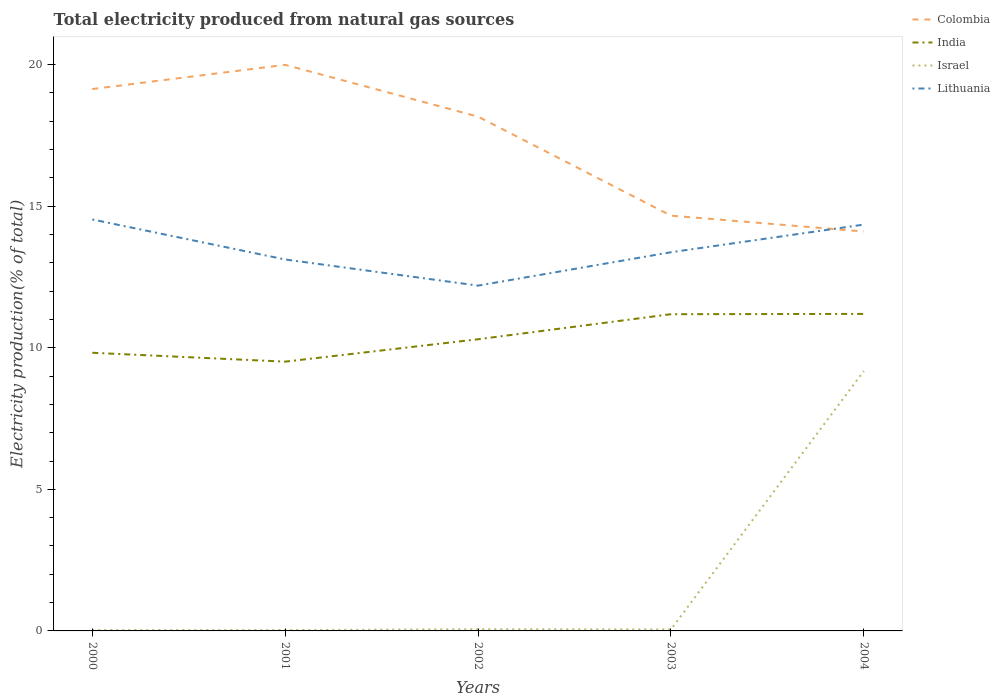How many different coloured lines are there?
Your response must be concise. 4. Does the line corresponding to Colombia intersect with the line corresponding to Lithuania?
Provide a succinct answer. Yes. Is the number of lines equal to the number of legend labels?
Your answer should be compact. Yes. Across all years, what is the maximum total electricity produced in Israel?
Your answer should be compact. 0.03. What is the total total electricity produced in Israel in the graph?
Provide a succinct answer. 0.01. What is the difference between the highest and the second highest total electricity produced in Lithuania?
Provide a succinct answer. 2.34. What is the difference between the highest and the lowest total electricity produced in Israel?
Provide a succinct answer. 1. Is the total electricity produced in Israel strictly greater than the total electricity produced in Colombia over the years?
Your response must be concise. Yes. How many lines are there?
Offer a very short reply. 4. How many years are there in the graph?
Give a very brief answer. 5. Where does the legend appear in the graph?
Your answer should be compact. Top right. How many legend labels are there?
Your answer should be very brief. 4. What is the title of the graph?
Make the answer very short. Total electricity produced from natural gas sources. Does "Austria" appear as one of the legend labels in the graph?
Give a very brief answer. No. What is the Electricity production(% of total) of Colombia in 2000?
Offer a terse response. 19.14. What is the Electricity production(% of total) in India in 2000?
Your response must be concise. 9.82. What is the Electricity production(% of total) in Israel in 2000?
Give a very brief answer. 0.03. What is the Electricity production(% of total) in Lithuania in 2000?
Your answer should be very brief. 14.53. What is the Electricity production(% of total) in Colombia in 2001?
Give a very brief answer. 19.99. What is the Electricity production(% of total) in India in 2001?
Your response must be concise. 9.51. What is the Electricity production(% of total) in Israel in 2001?
Give a very brief answer. 0.03. What is the Electricity production(% of total) in Lithuania in 2001?
Provide a succinct answer. 13.12. What is the Electricity production(% of total) of Colombia in 2002?
Provide a short and direct response. 18.16. What is the Electricity production(% of total) of India in 2002?
Make the answer very short. 10.3. What is the Electricity production(% of total) in Israel in 2002?
Your answer should be compact. 0.06. What is the Electricity production(% of total) of Lithuania in 2002?
Your response must be concise. 12.19. What is the Electricity production(% of total) of Colombia in 2003?
Give a very brief answer. 14.67. What is the Electricity production(% of total) of India in 2003?
Make the answer very short. 11.19. What is the Electricity production(% of total) in Israel in 2003?
Your response must be concise. 0.05. What is the Electricity production(% of total) of Lithuania in 2003?
Provide a succinct answer. 13.37. What is the Electricity production(% of total) in Colombia in 2004?
Your answer should be compact. 14.11. What is the Electricity production(% of total) in India in 2004?
Keep it short and to the point. 11.2. What is the Electricity production(% of total) of Israel in 2004?
Your answer should be very brief. 9.18. What is the Electricity production(% of total) in Lithuania in 2004?
Keep it short and to the point. 14.35. Across all years, what is the maximum Electricity production(% of total) of Colombia?
Offer a very short reply. 19.99. Across all years, what is the maximum Electricity production(% of total) in India?
Your answer should be compact. 11.2. Across all years, what is the maximum Electricity production(% of total) in Israel?
Your answer should be very brief. 9.18. Across all years, what is the maximum Electricity production(% of total) in Lithuania?
Ensure brevity in your answer.  14.53. Across all years, what is the minimum Electricity production(% of total) in Colombia?
Your response must be concise. 14.11. Across all years, what is the minimum Electricity production(% of total) in India?
Make the answer very short. 9.51. Across all years, what is the minimum Electricity production(% of total) of Israel?
Offer a terse response. 0.03. Across all years, what is the minimum Electricity production(% of total) of Lithuania?
Keep it short and to the point. 12.19. What is the total Electricity production(% of total) in Colombia in the graph?
Ensure brevity in your answer.  86.06. What is the total Electricity production(% of total) in India in the graph?
Keep it short and to the point. 52.02. What is the total Electricity production(% of total) in Israel in the graph?
Keep it short and to the point. 9.36. What is the total Electricity production(% of total) of Lithuania in the graph?
Keep it short and to the point. 67.57. What is the difference between the Electricity production(% of total) of Colombia in 2000 and that in 2001?
Your response must be concise. -0.85. What is the difference between the Electricity production(% of total) of India in 2000 and that in 2001?
Your answer should be very brief. 0.31. What is the difference between the Electricity production(% of total) of Israel in 2000 and that in 2001?
Make the answer very short. 0. What is the difference between the Electricity production(% of total) of Lithuania in 2000 and that in 2001?
Your answer should be very brief. 1.41. What is the difference between the Electricity production(% of total) in Colombia in 2000 and that in 2002?
Your answer should be compact. 0.97. What is the difference between the Electricity production(% of total) of India in 2000 and that in 2002?
Your answer should be very brief. -0.48. What is the difference between the Electricity production(% of total) of Israel in 2000 and that in 2002?
Your answer should be very brief. -0.03. What is the difference between the Electricity production(% of total) in Lithuania in 2000 and that in 2002?
Your response must be concise. 2.34. What is the difference between the Electricity production(% of total) in Colombia in 2000 and that in 2003?
Your answer should be very brief. 4.47. What is the difference between the Electricity production(% of total) of India in 2000 and that in 2003?
Offer a terse response. -1.36. What is the difference between the Electricity production(% of total) in Israel in 2000 and that in 2003?
Offer a terse response. -0.02. What is the difference between the Electricity production(% of total) in Lithuania in 2000 and that in 2003?
Keep it short and to the point. 1.16. What is the difference between the Electricity production(% of total) in Colombia in 2000 and that in 2004?
Offer a terse response. 5.03. What is the difference between the Electricity production(% of total) in India in 2000 and that in 2004?
Your answer should be very brief. -1.37. What is the difference between the Electricity production(% of total) of Israel in 2000 and that in 2004?
Ensure brevity in your answer.  -9.15. What is the difference between the Electricity production(% of total) of Lithuania in 2000 and that in 2004?
Make the answer very short. 0.18. What is the difference between the Electricity production(% of total) in Colombia in 2001 and that in 2002?
Your response must be concise. 1.83. What is the difference between the Electricity production(% of total) of India in 2001 and that in 2002?
Keep it short and to the point. -0.79. What is the difference between the Electricity production(% of total) of Israel in 2001 and that in 2002?
Offer a terse response. -0.03. What is the difference between the Electricity production(% of total) of Lithuania in 2001 and that in 2002?
Provide a short and direct response. 0.92. What is the difference between the Electricity production(% of total) in Colombia in 2001 and that in 2003?
Your response must be concise. 5.33. What is the difference between the Electricity production(% of total) of India in 2001 and that in 2003?
Give a very brief answer. -1.68. What is the difference between the Electricity production(% of total) in Israel in 2001 and that in 2003?
Your response must be concise. -0.02. What is the difference between the Electricity production(% of total) of Lithuania in 2001 and that in 2003?
Ensure brevity in your answer.  -0.26. What is the difference between the Electricity production(% of total) of Colombia in 2001 and that in 2004?
Your answer should be compact. 5.89. What is the difference between the Electricity production(% of total) of India in 2001 and that in 2004?
Keep it short and to the point. -1.69. What is the difference between the Electricity production(% of total) in Israel in 2001 and that in 2004?
Provide a short and direct response. -9.15. What is the difference between the Electricity production(% of total) in Lithuania in 2001 and that in 2004?
Provide a succinct answer. -1.23. What is the difference between the Electricity production(% of total) in Colombia in 2002 and that in 2003?
Your answer should be very brief. 3.5. What is the difference between the Electricity production(% of total) of India in 2002 and that in 2003?
Your answer should be compact. -0.89. What is the difference between the Electricity production(% of total) in Israel in 2002 and that in 2003?
Your answer should be compact. 0.01. What is the difference between the Electricity production(% of total) of Lithuania in 2002 and that in 2003?
Provide a short and direct response. -1.18. What is the difference between the Electricity production(% of total) of Colombia in 2002 and that in 2004?
Offer a terse response. 4.06. What is the difference between the Electricity production(% of total) in India in 2002 and that in 2004?
Ensure brevity in your answer.  -0.9. What is the difference between the Electricity production(% of total) in Israel in 2002 and that in 2004?
Provide a short and direct response. -9.12. What is the difference between the Electricity production(% of total) of Lithuania in 2002 and that in 2004?
Give a very brief answer. -2.16. What is the difference between the Electricity production(% of total) of Colombia in 2003 and that in 2004?
Provide a short and direct response. 0.56. What is the difference between the Electricity production(% of total) in India in 2003 and that in 2004?
Provide a short and direct response. -0.01. What is the difference between the Electricity production(% of total) of Israel in 2003 and that in 2004?
Provide a succinct answer. -9.13. What is the difference between the Electricity production(% of total) of Lithuania in 2003 and that in 2004?
Provide a short and direct response. -0.98. What is the difference between the Electricity production(% of total) of Colombia in 2000 and the Electricity production(% of total) of India in 2001?
Provide a short and direct response. 9.63. What is the difference between the Electricity production(% of total) in Colombia in 2000 and the Electricity production(% of total) in Israel in 2001?
Offer a terse response. 19.11. What is the difference between the Electricity production(% of total) of Colombia in 2000 and the Electricity production(% of total) of Lithuania in 2001?
Offer a very short reply. 6.02. What is the difference between the Electricity production(% of total) in India in 2000 and the Electricity production(% of total) in Israel in 2001?
Offer a very short reply. 9.79. What is the difference between the Electricity production(% of total) of India in 2000 and the Electricity production(% of total) of Lithuania in 2001?
Offer a very short reply. -3.29. What is the difference between the Electricity production(% of total) in Israel in 2000 and the Electricity production(% of total) in Lithuania in 2001?
Keep it short and to the point. -13.09. What is the difference between the Electricity production(% of total) of Colombia in 2000 and the Electricity production(% of total) of India in 2002?
Make the answer very short. 8.84. What is the difference between the Electricity production(% of total) in Colombia in 2000 and the Electricity production(% of total) in Israel in 2002?
Make the answer very short. 19.08. What is the difference between the Electricity production(% of total) in Colombia in 2000 and the Electricity production(% of total) in Lithuania in 2002?
Keep it short and to the point. 6.94. What is the difference between the Electricity production(% of total) of India in 2000 and the Electricity production(% of total) of Israel in 2002?
Give a very brief answer. 9.76. What is the difference between the Electricity production(% of total) of India in 2000 and the Electricity production(% of total) of Lithuania in 2002?
Ensure brevity in your answer.  -2.37. What is the difference between the Electricity production(% of total) of Israel in 2000 and the Electricity production(% of total) of Lithuania in 2002?
Make the answer very short. -12.16. What is the difference between the Electricity production(% of total) of Colombia in 2000 and the Electricity production(% of total) of India in 2003?
Provide a short and direct response. 7.95. What is the difference between the Electricity production(% of total) in Colombia in 2000 and the Electricity production(% of total) in Israel in 2003?
Your response must be concise. 19.08. What is the difference between the Electricity production(% of total) of Colombia in 2000 and the Electricity production(% of total) of Lithuania in 2003?
Ensure brevity in your answer.  5.76. What is the difference between the Electricity production(% of total) in India in 2000 and the Electricity production(% of total) in Israel in 2003?
Your answer should be compact. 9.77. What is the difference between the Electricity production(% of total) in India in 2000 and the Electricity production(% of total) in Lithuania in 2003?
Offer a very short reply. -3.55. What is the difference between the Electricity production(% of total) of Israel in 2000 and the Electricity production(% of total) of Lithuania in 2003?
Your response must be concise. -13.34. What is the difference between the Electricity production(% of total) of Colombia in 2000 and the Electricity production(% of total) of India in 2004?
Keep it short and to the point. 7.94. What is the difference between the Electricity production(% of total) in Colombia in 2000 and the Electricity production(% of total) in Israel in 2004?
Your response must be concise. 9.96. What is the difference between the Electricity production(% of total) of Colombia in 2000 and the Electricity production(% of total) of Lithuania in 2004?
Offer a terse response. 4.79. What is the difference between the Electricity production(% of total) in India in 2000 and the Electricity production(% of total) in Israel in 2004?
Provide a short and direct response. 0.64. What is the difference between the Electricity production(% of total) in India in 2000 and the Electricity production(% of total) in Lithuania in 2004?
Ensure brevity in your answer.  -4.53. What is the difference between the Electricity production(% of total) in Israel in 2000 and the Electricity production(% of total) in Lithuania in 2004?
Offer a very short reply. -14.32. What is the difference between the Electricity production(% of total) of Colombia in 2001 and the Electricity production(% of total) of India in 2002?
Your answer should be very brief. 9.69. What is the difference between the Electricity production(% of total) of Colombia in 2001 and the Electricity production(% of total) of Israel in 2002?
Make the answer very short. 19.93. What is the difference between the Electricity production(% of total) in Colombia in 2001 and the Electricity production(% of total) in Lithuania in 2002?
Your answer should be compact. 7.8. What is the difference between the Electricity production(% of total) in India in 2001 and the Electricity production(% of total) in Israel in 2002?
Give a very brief answer. 9.45. What is the difference between the Electricity production(% of total) in India in 2001 and the Electricity production(% of total) in Lithuania in 2002?
Your answer should be very brief. -2.69. What is the difference between the Electricity production(% of total) of Israel in 2001 and the Electricity production(% of total) of Lithuania in 2002?
Make the answer very short. -12.17. What is the difference between the Electricity production(% of total) in Colombia in 2001 and the Electricity production(% of total) in India in 2003?
Make the answer very short. 8.81. What is the difference between the Electricity production(% of total) of Colombia in 2001 and the Electricity production(% of total) of Israel in 2003?
Provide a short and direct response. 19.94. What is the difference between the Electricity production(% of total) of Colombia in 2001 and the Electricity production(% of total) of Lithuania in 2003?
Your answer should be compact. 6.62. What is the difference between the Electricity production(% of total) of India in 2001 and the Electricity production(% of total) of Israel in 2003?
Ensure brevity in your answer.  9.46. What is the difference between the Electricity production(% of total) of India in 2001 and the Electricity production(% of total) of Lithuania in 2003?
Give a very brief answer. -3.86. What is the difference between the Electricity production(% of total) in Israel in 2001 and the Electricity production(% of total) in Lithuania in 2003?
Offer a terse response. -13.34. What is the difference between the Electricity production(% of total) in Colombia in 2001 and the Electricity production(% of total) in India in 2004?
Ensure brevity in your answer.  8.8. What is the difference between the Electricity production(% of total) in Colombia in 2001 and the Electricity production(% of total) in Israel in 2004?
Keep it short and to the point. 10.81. What is the difference between the Electricity production(% of total) in Colombia in 2001 and the Electricity production(% of total) in Lithuania in 2004?
Your response must be concise. 5.64. What is the difference between the Electricity production(% of total) in India in 2001 and the Electricity production(% of total) in Israel in 2004?
Your answer should be compact. 0.33. What is the difference between the Electricity production(% of total) of India in 2001 and the Electricity production(% of total) of Lithuania in 2004?
Provide a succinct answer. -4.84. What is the difference between the Electricity production(% of total) of Israel in 2001 and the Electricity production(% of total) of Lithuania in 2004?
Make the answer very short. -14.32. What is the difference between the Electricity production(% of total) in Colombia in 2002 and the Electricity production(% of total) in India in 2003?
Offer a very short reply. 6.98. What is the difference between the Electricity production(% of total) of Colombia in 2002 and the Electricity production(% of total) of Israel in 2003?
Your response must be concise. 18.11. What is the difference between the Electricity production(% of total) in Colombia in 2002 and the Electricity production(% of total) in Lithuania in 2003?
Make the answer very short. 4.79. What is the difference between the Electricity production(% of total) of India in 2002 and the Electricity production(% of total) of Israel in 2003?
Provide a short and direct response. 10.25. What is the difference between the Electricity production(% of total) of India in 2002 and the Electricity production(% of total) of Lithuania in 2003?
Offer a terse response. -3.07. What is the difference between the Electricity production(% of total) in Israel in 2002 and the Electricity production(% of total) in Lithuania in 2003?
Your answer should be very brief. -13.31. What is the difference between the Electricity production(% of total) of Colombia in 2002 and the Electricity production(% of total) of India in 2004?
Your response must be concise. 6.97. What is the difference between the Electricity production(% of total) in Colombia in 2002 and the Electricity production(% of total) in Israel in 2004?
Offer a very short reply. 8.98. What is the difference between the Electricity production(% of total) of Colombia in 2002 and the Electricity production(% of total) of Lithuania in 2004?
Make the answer very short. 3.81. What is the difference between the Electricity production(% of total) of India in 2002 and the Electricity production(% of total) of Israel in 2004?
Keep it short and to the point. 1.12. What is the difference between the Electricity production(% of total) in India in 2002 and the Electricity production(% of total) in Lithuania in 2004?
Ensure brevity in your answer.  -4.05. What is the difference between the Electricity production(% of total) of Israel in 2002 and the Electricity production(% of total) of Lithuania in 2004?
Your answer should be very brief. -14.29. What is the difference between the Electricity production(% of total) of Colombia in 2003 and the Electricity production(% of total) of India in 2004?
Offer a terse response. 3.47. What is the difference between the Electricity production(% of total) of Colombia in 2003 and the Electricity production(% of total) of Israel in 2004?
Offer a very short reply. 5.49. What is the difference between the Electricity production(% of total) of Colombia in 2003 and the Electricity production(% of total) of Lithuania in 2004?
Your answer should be compact. 0.32. What is the difference between the Electricity production(% of total) in India in 2003 and the Electricity production(% of total) in Israel in 2004?
Provide a short and direct response. 2. What is the difference between the Electricity production(% of total) in India in 2003 and the Electricity production(% of total) in Lithuania in 2004?
Offer a terse response. -3.16. What is the difference between the Electricity production(% of total) in Israel in 2003 and the Electricity production(% of total) in Lithuania in 2004?
Provide a short and direct response. -14.3. What is the average Electricity production(% of total) in Colombia per year?
Your answer should be very brief. 17.21. What is the average Electricity production(% of total) of India per year?
Offer a terse response. 10.4. What is the average Electricity production(% of total) of Israel per year?
Make the answer very short. 1.87. What is the average Electricity production(% of total) of Lithuania per year?
Provide a short and direct response. 13.51. In the year 2000, what is the difference between the Electricity production(% of total) in Colombia and Electricity production(% of total) in India?
Provide a succinct answer. 9.31. In the year 2000, what is the difference between the Electricity production(% of total) in Colombia and Electricity production(% of total) in Israel?
Provide a short and direct response. 19.11. In the year 2000, what is the difference between the Electricity production(% of total) of Colombia and Electricity production(% of total) of Lithuania?
Your answer should be compact. 4.61. In the year 2000, what is the difference between the Electricity production(% of total) of India and Electricity production(% of total) of Israel?
Keep it short and to the point. 9.79. In the year 2000, what is the difference between the Electricity production(% of total) in India and Electricity production(% of total) in Lithuania?
Your answer should be very brief. -4.71. In the year 2000, what is the difference between the Electricity production(% of total) of Israel and Electricity production(% of total) of Lithuania?
Offer a terse response. -14.5. In the year 2001, what is the difference between the Electricity production(% of total) in Colombia and Electricity production(% of total) in India?
Ensure brevity in your answer.  10.48. In the year 2001, what is the difference between the Electricity production(% of total) of Colombia and Electricity production(% of total) of Israel?
Offer a very short reply. 19.96. In the year 2001, what is the difference between the Electricity production(% of total) of Colombia and Electricity production(% of total) of Lithuania?
Provide a succinct answer. 6.87. In the year 2001, what is the difference between the Electricity production(% of total) in India and Electricity production(% of total) in Israel?
Provide a short and direct response. 9.48. In the year 2001, what is the difference between the Electricity production(% of total) in India and Electricity production(% of total) in Lithuania?
Ensure brevity in your answer.  -3.61. In the year 2001, what is the difference between the Electricity production(% of total) in Israel and Electricity production(% of total) in Lithuania?
Your answer should be compact. -13.09. In the year 2002, what is the difference between the Electricity production(% of total) in Colombia and Electricity production(% of total) in India?
Make the answer very short. 7.86. In the year 2002, what is the difference between the Electricity production(% of total) in Colombia and Electricity production(% of total) in Israel?
Your answer should be compact. 18.1. In the year 2002, what is the difference between the Electricity production(% of total) in Colombia and Electricity production(% of total) in Lithuania?
Offer a terse response. 5.97. In the year 2002, what is the difference between the Electricity production(% of total) in India and Electricity production(% of total) in Israel?
Provide a succinct answer. 10.24. In the year 2002, what is the difference between the Electricity production(% of total) in India and Electricity production(% of total) in Lithuania?
Offer a terse response. -1.89. In the year 2002, what is the difference between the Electricity production(% of total) in Israel and Electricity production(% of total) in Lithuania?
Your answer should be very brief. -12.13. In the year 2003, what is the difference between the Electricity production(% of total) in Colombia and Electricity production(% of total) in India?
Make the answer very short. 3.48. In the year 2003, what is the difference between the Electricity production(% of total) of Colombia and Electricity production(% of total) of Israel?
Your answer should be very brief. 14.61. In the year 2003, what is the difference between the Electricity production(% of total) of Colombia and Electricity production(% of total) of Lithuania?
Ensure brevity in your answer.  1.29. In the year 2003, what is the difference between the Electricity production(% of total) of India and Electricity production(% of total) of Israel?
Give a very brief answer. 11.13. In the year 2003, what is the difference between the Electricity production(% of total) in India and Electricity production(% of total) in Lithuania?
Ensure brevity in your answer.  -2.19. In the year 2003, what is the difference between the Electricity production(% of total) in Israel and Electricity production(% of total) in Lithuania?
Your answer should be very brief. -13.32. In the year 2004, what is the difference between the Electricity production(% of total) of Colombia and Electricity production(% of total) of India?
Your response must be concise. 2.91. In the year 2004, what is the difference between the Electricity production(% of total) in Colombia and Electricity production(% of total) in Israel?
Ensure brevity in your answer.  4.92. In the year 2004, what is the difference between the Electricity production(% of total) of Colombia and Electricity production(% of total) of Lithuania?
Offer a terse response. -0.25. In the year 2004, what is the difference between the Electricity production(% of total) of India and Electricity production(% of total) of Israel?
Your answer should be compact. 2.01. In the year 2004, what is the difference between the Electricity production(% of total) of India and Electricity production(% of total) of Lithuania?
Offer a very short reply. -3.15. In the year 2004, what is the difference between the Electricity production(% of total) in Israel and Electricity production(% of total) in Lithuania?
Your answer should be very brief. -5.17. What is the ratio of the Electricity production(% of total) of Colombia in 2000 to that in 2001?
Offer a very short reply. 0.96. What is the ratio of the Electricity production(% of total) in India in 2000 to that in 2001?
Make the answer very short. 1.03. What is the ratio of the Electricity production(% of total) in Israel in 2000 to that in 2001?
Keep it short and to the point. 1.03. What is the ratio of the Electricity production(% of total) of Lithuania in 2000 to that in 2001?
Ensure brevity in your answer.  1.11. What is the ratio of the Electricity production(% of total) in Colombia in 2000 to that in 2002?
Offer a terse response. 1.05. What is the ratio of the Electricity production(% of total) of India in 2000 to that in 2002?
Your answer should be very brief. 0.95. What is the ratio of the Electricity production(% of total) of Israel in 2000 to that in 2002?
Your response must be concise. 0.5. What is the ratio of the Electricity production(% of total) of Lithuania in 2000 to that in 2002?
Provide a short and direct response. 1.19. What is the ratio of the Electricity production(% of total) in Colombia in 2000 to that in 2003?
Your response must be concise. 1.3. What is the ratio of the Electricity production(% of total) in India in 2000 to that in 2003?
Offer a very short reply. 0.88. What is the ratio of the Electricity production(% of total) of Israel in 2000 to that in 2003?
Provide a succinct answer. 0.57. What is the ratio of the Electricity production(% of total) in Lithuania in 2000 to that in 2003?
Offer a terse response. 1.09. What is the ratio of the Electricity production(% of total) of Colombia in 2000 to that in 2004?
Provide a succinct answer. 1.36. What is the ratio of the Electricity production(% of total) in India in 2000 to that in 2004?
Offer a terse response. 0.88. What is the ratio of the Electricity production(% of total) of Israel in 2000 to that in 2004?
Provide a short and direct response. 0. What is the ratio of the Electricity production(% of total) in Lithuania in 2000 to that in 2004?
Give a very brief answer. 1.01. What is the ratio of the Electricity production(% of total) in Colombia in 2001 to that in 2002?
Your answer should be compact. 1.1. What is the ratio of the Electricity production(% of total) of India in 2001 to that in 2002?
Provide a succinct answer. 0.92. What is the ratio of the Electricity production(% of total) in Israel in 2001 to that in 2002?
Ensure brevity in your answer.  0.48. What is the ratio of the Electricity production(% of total) of Lithuania in 2001 to that in 2002?
Your answer should be compact. 1.08. What is the ratio of the Electricity production(% of total) of Colombia in 2001 to that in 2003?
Offer a terse response. 1.36. What is the ratio of the Electricity production(% of total) in India in 2001 to that in 2003?
Make the answer very short. 0.85. What is the ratio of the Electricity production(% of total) of Israel in 2001 to that in 2003?
Provide a succinct answer. 0.56. What is the ratio of the Electricity production(% of total) of Lithuania in 2001 to that in 2003?
Your response must be concise. 0.98. What is the ratio of the Electricity production(% of total) of Colombia in 2001 to that in 2004?
Give a very brief answer. 1.42. What is the ratio of the Electricity production(% of total) in India in 2001 to that in 2004?
Provide a short and direct response. 0.85. What is the ratio of the Electricity production(% of total) of Israel in 2001 to that in 2004?
Your response must be concise. 0. What is the ratio of the Electricity production(% of total) in Lithuania in 2001 to that in 2004?
Your answer should be very brief. 0.91. What is the ratio of the Electricity production(% of total) in Colombia in 2002 to that in 2003?
Offer a very short reply. 1.24. What is the ratio of the Electricity production(% of total) of India in 2002 to that in 2003?
Make the answer very short. 0.92. What is the ratio of the Electricity production(% of total) of Israel in 2002 to that in 2003?
Keep it short and to the point. 1.16. What is the ratio of the Electricity production(% of total) in Lithuania in 2002 to that in 2003?
Provide a short and direct response. 0.91. What is the ratio of the Electricity production(% of total) of Colombia in 2002 to that in 2004?
Make the answer very short. 1.29. What is the ratio of the Electricity production(% of total) of India in 2002 to that in 2004?
Your answer should be compact. 0.92. What is the ratio of the Electricity production(% of total) in Israel in 2002 to that in 2004?
Give a very brief answer. 0.01. What is the ratio of the Electricity production(% of total) in Lithuania in 2002 to that in 2004?
Offer a terse response. 0.85. What is the ratio of the Electricity production(% of total) in Colombia in 2003 to that in 2004?
Provide a short and direct response. 1.04. What is the ratio of the Electricity production(% of total) in Israel in 2003 to that in 2004?
Offer a very short reply. 0.01. What is the ratio of the Electricity production(% of total) of Lithuania in 2003 to that in 2004?
Your answer should be very brief. 0.93. What is the difference between the highest and the second highest Electricity production(% of total) of Colombia?
Keep it short and to the point. 0.85. What is the difference between the highest and the second highest Electricity production(% of total) of India?
Ensure brevity in your answer.  0.01. What is the difference between the highest and the second highest Electricity production(% of total) of Israel?
Make the answer very short. 9.12. What is the difference between the highest and the second highest Electricity production(% of total) in Lithuania?
Your answer should be compact. 0.18. What is the difference between the highest and the lowest Electricity production(% of total) in Colombia?
Your response must be concise. 5.89. What is the difference between the highest and the lowest Electricity production(% of total) of India?
Offer a very short reply. 1.69. What is the difference between the highest and the lowest Electricity production(% of total) in Israel?
Offer a terse response. 9.15. What is the difference between the highest and the lowest Electricity production(% of total) of Lithuania?
Provide a succinct answer. 2.34. 